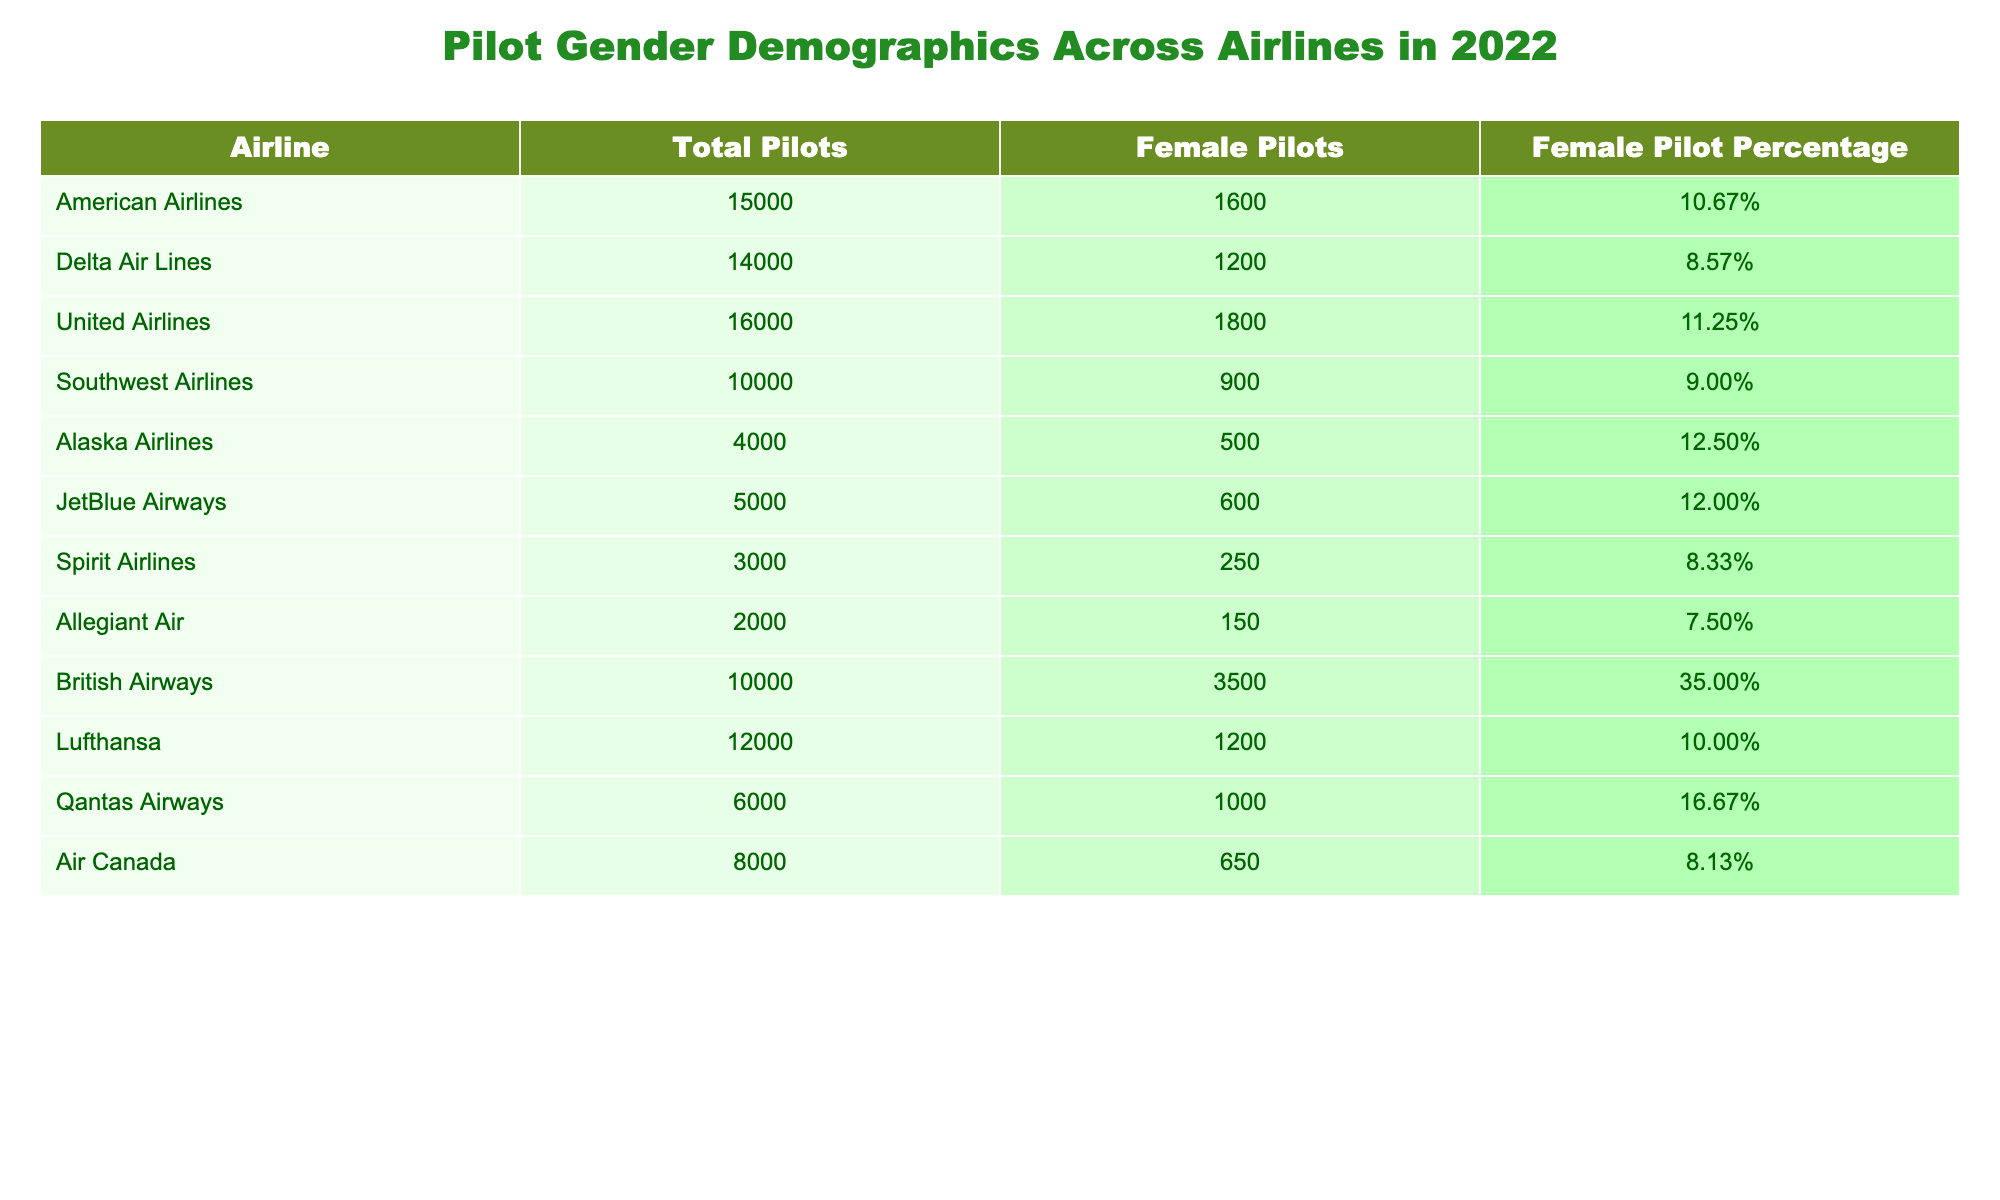What percentage of pilots at British Airways are female? According to the table, the Female Pilot Percentage for British Airways is listed as 35.00%.
Answer: 35.00% Which airline has the highest number of female pilots? Looking at the table, British Airways has the most female pilots, with a total of 3500.
Answer: British Airways What is the total number of pilots at United Airlines and Southwest Airlines combined? By adding the Total Pilots for United Airlines (16000) and Southwest Airlines (10000), we get 16000 + 10000 = 26000.
Answer: 26000 Is the percentage of female pilots at Alaska Airlines higher than that at American Airlines? Comparing the Female Pilot Percentages, Alaska Airlines has 12.50% while American Airlines has 10.67%. Since 12.50% is greater than 10.67%, the answer is yes.
Answer: Yes What is the average percentage of female pilots across all listed airlines? To find the average, first, we sum all the female pilot percentages: 10.67 + 8.57 + 11.25 + 9.00 + 12.50 + 12.00 + 8.33 + 7.50 + 35.00 + 10.00 + 16.67 + 8.13 =  302.12. Now dividing by the number of airlines (12), 302.12 / 12 = 25.18, thus the average is approximately 25.18%.
Answer: 25.18% What percentage of pilots at JetBlue Airways are female? The Female Pilot Percentage for JetBlue Airways is given as 12.00%.
Answer: 12.00% Does Spirit Airlines have a higher percentage of female pilots than Allegiant Air? Spirit Airlines has a percentage of 8.33% and Allegiant Air has 7.50%. Since 8.33% is greater than 7.50%, the answer is yes.
Answer: Yes How many more female pilots does Qantas Airways have compared to Delta Air Lines? Qantas Airways has 1000 female pilots and Delta Air Lines has 1200. By calculating 1000 - 1200, we find that Qantas has 200 fewer female pilots than Delta.
Answer: 200 fewer What is the total number of female pilots from all airlines combined? Summing the Female Pilots from all airlines: 1600 + 1200 + 1800 + 900 + 500 + 600 + 250 + 150 + 3500 + 1200 + 1000 + 650 = 12450.
Answer: 12450 